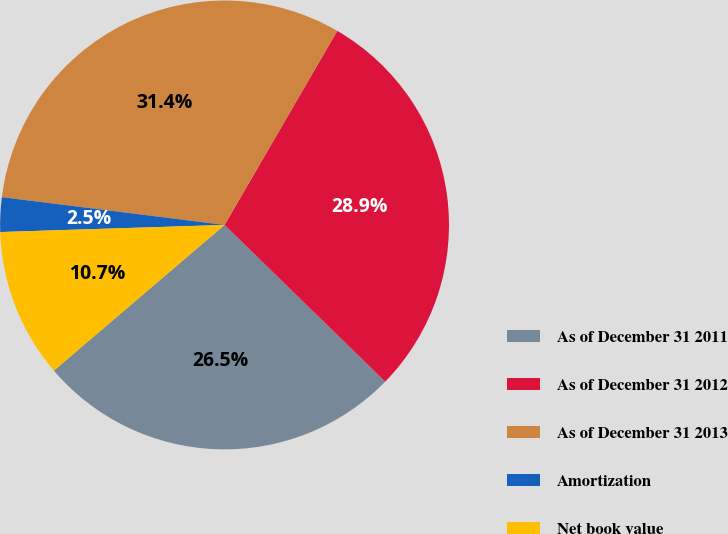Convert chart. <chart><loc_0><loc_0><loc_500><loc_500><pie_chart><fcel>As of December 31 2011<fcel>As of December 31 2012<fcel>As of December 31 2013<fcel>Amortization<fcel>Net book value<nl><fcel>26.45%<fcel>28.93%<fcel>31.4%<fcel>2.48%<fcel>10.74%<nl></chart> 